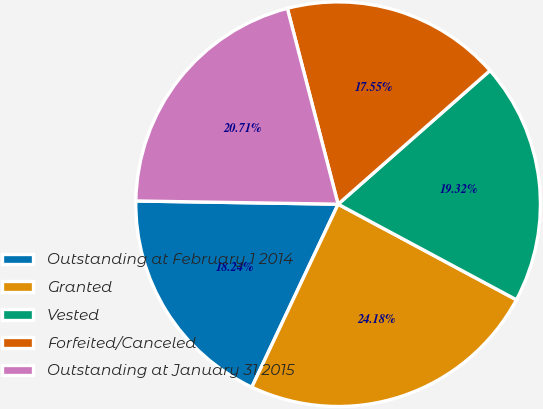Convert chart. <chart><loc_0><loc_0><loc_500><loc_500><pie_chart><fcel>Outstanding at February 1 2014<fcel>Granted<fcel>Vested<fcel>Forfeited/Canceled<fcel>Outstanding at January 31 2015<nl><fcel>18.24%<fcel>24.18%<fcel>19.32%<fcel>17.55%<fcel>20.71%<nl></chart> 